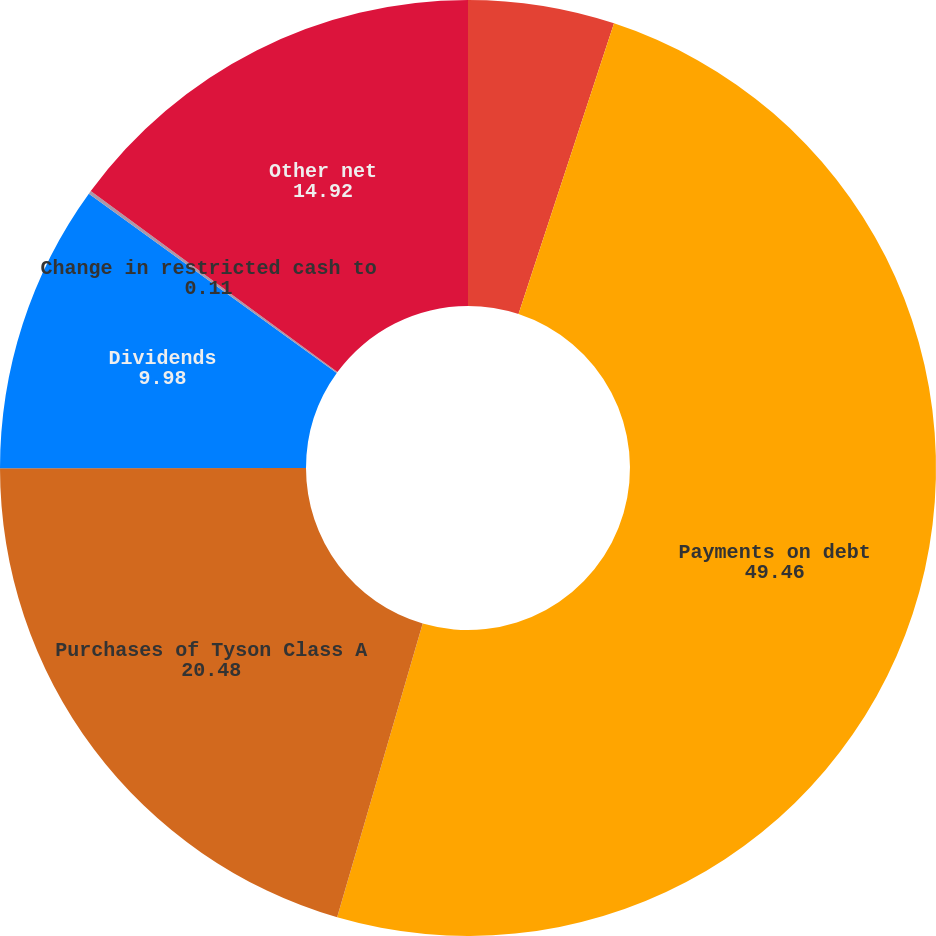Convert chart to OTSL. <chart><loc_0><loc_0><loc_500><loc_500><pie_chart><fcel>Net borrowings (payments) on<fcel>Payments on debt<fcel>Purchases of Tyson Class A<fcel>Dividends<fcel>Change in restricted cash to<fcel>Other net<nl><fcel>5.05%<fcel>49.46%<fcel>20.48%<fcel>9.98%<fcel>0.11%<fcel>14.92%<nl></chart> 